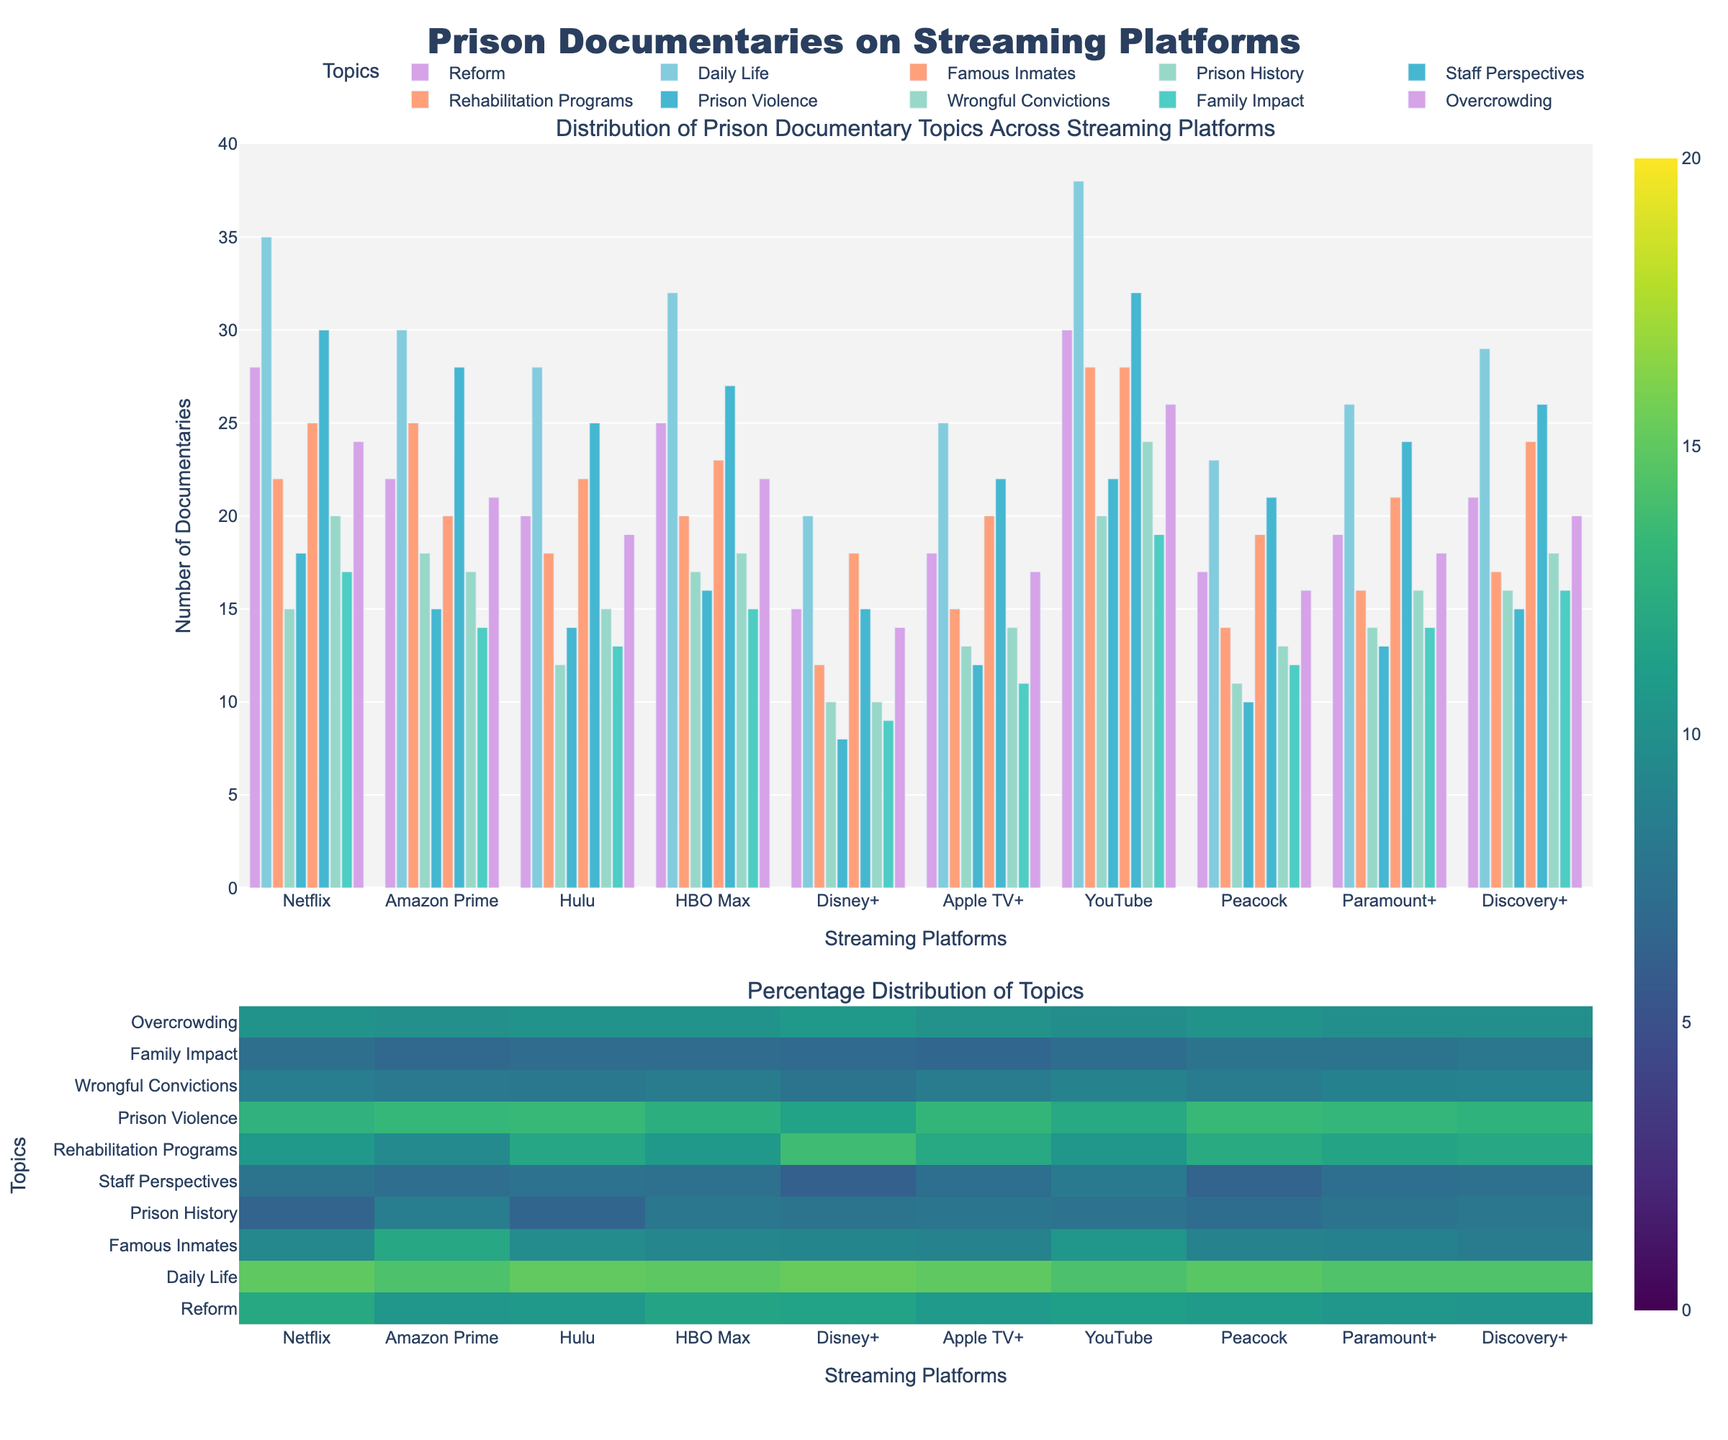What platform has the highest number of documentaries about "Daily Life"? The highest bar in the "Daily Life" category corresponds to YouTube. By looking at the height of the bars, the YouTube section has the tallest bar for "Daily Life".
Answer: YouTube Which platform has the least content related to "Famous Inmates"? By comparing all the bars in the "Famous Inmates" category, Disney+ has the shortest bar.
Answer: Disney+ How many documentaries related to "Reform" are there in total on Netflix and Hulu combined? Add the number of "Reform" documentaries on Netflix (28) and Hulu (20). The sum is 28 + 20.
Answer: 48 Is the number of documentaries on "Prison Violence" greater on Amazon Prime or HBO Max? Compare the heights of the bars for "Prison Violence" for both Amazon Prime and HBO Max. Amazon Prime has 28 while HBO Max has 27. Therefore, Amazon Prime has more documentaries on this topic.
Answer: Amazon Prime What is the average number of documentaries about "Rehabilitation Programs" across all platforms? Sum the "Rehabilitation Programs" values for all platforms and then divide by the number of platforms. The calculation is (25 + 20 + 22 + 23 + 18 + 20 + 28 + 19 + 21 + 24) / 10 = 22.
Answer: 22 Which platform has the most balanced spread across all topics? Look at the bar heights across all categories for each platform to see which one has the most consistent (or least varying) heights. Generally, HBO Max and Discovery+ appear to have a balanced distribution compared to others, but a precise calculation would be needed for an exact answer.
Answer: HBO Max or Discovery+ Are there more documentaries related to "Family Impact" or "Overcrowding" on all platforms combined? Sum up the "Family Impact" and "Overcrowding" values across all platforms, then compare the totals. "Family Impact" total: 17 + 14 + 13 + 15 + 9 + 11 + 19 + 12 + 14 + 16 = 140. "Overcrowding" total: 24 + 21 + 19 + 22 + 14 + 17 + 26 + 16 + 18 + 20 = 197. Overcrowding has more documentaries.
Answer: Overcrowding Which platform has the highest percentage of its documentaries focused on "Prison History"? Refer to the heatmap in the lower part of the plot. By looking at the y-axis labeled "Prison History" and comparing the intensity of colors, YouTube appears to have a higher percentage compared to other platforms.
Answer: YouTube If you combine the documentaries about "Wrongful Convictions" and "Family Impact" on Amazon Prime, do they exceed those on Netflix? Sum the "Wrongful Convictions" and "Family Impact" values for Amazon Prime and compare with the sum of Netflix. Amazon Prime: 17 + 14 = 31 and Netflix: 20 + 17 = 37. Netflix has more.
Answer: No Which topic has the highest overall coverage across all platforms? Sum up the values for each topic across all platforms and compare the sums. "Daily Life" with (35 + 30 + 28 + 32 + 20 + 25 + 38 + 23 + 26 + 29) = 286 has the highest overall coverage.
Answer: Daily Life 